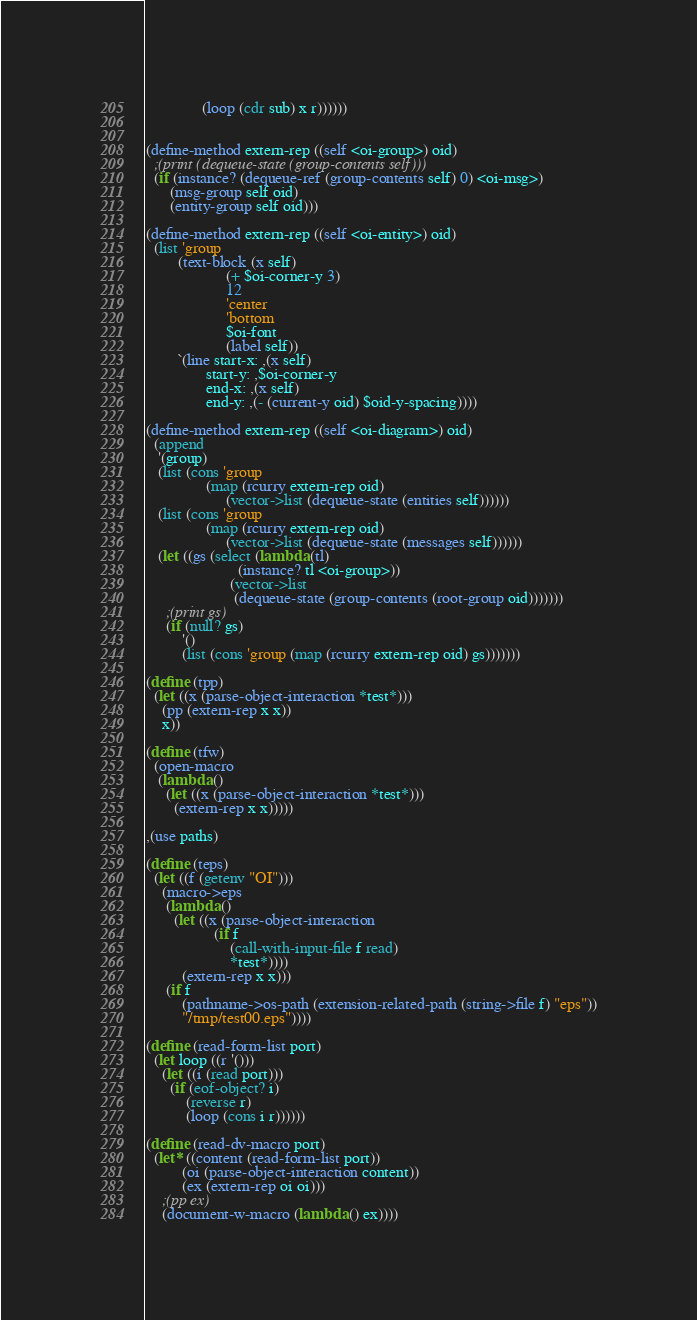Convert code to text. <code><loc_0><loc_0><loc_500><loc_500><_Scheme_>              (loop (cdr sub) x r))))))
        

(define-method extern-rep ((self <oi-group>) oid)
  ;(print (dequeue-state (group-contents self)))
  (if (instance? (dequeue-ref (group-contents self) 0) <oi-msg>)
      (msg-group self oid)
      (entity-group self oid)))

(define-method extern-rep ((self <oi-entity>) oid)
  (list 'group
        (text-block (x self)
                    (+ $oi-corner-y 3)
                    12
                    'center
                    'bottom
                    $oi-font
                    (label self))
        `(line start-x: ,(x self)
               start-y: ,$oi-corner-y
               end-x: ,(x self)
               end-y: ,(- (current-y oid) $oid-y-spacing))))
          
(define-method extern-rep ((self <oi-diagram>) oid)
  (append
   '(group)
   (list (cons 'group
               (map (rcurry extern-rep oid)
                    (vector->list (dequeue-state (entities self))))))
   (list (cons 'group
               (map (rcurry extern-rep oid)
                    (vector->list (dequeue-state (messages self))))))
   (let ((gs (select (lambda (tl)
                       (instance? tl <oi-group>))
                     (vector->list
                      (dequeue-state (group-contents (root-group oid)))))))
     ;(print gs)
     (if (null? gs)
         '()
         (list (cons 'group (map (rcurry extern-rep oid) gs)))))))

(define (tpp)
  (let ((x (parse-object-interaction *test*)))
    (pp (extern-rep x x))
    x))

(define (tfw)
  (open-macro
   (lambda ()
     (let ((x (parse-object-interaction *test*)))
       (extern-rep x x)))))

,(use paths)

(define (teps)
  (let ((f (getenv "OI")))
    (macro->eps
     (lambda ()
       (let ((x (parse-object-interaction 
                 (if f
                     (call-with-input-file f read)
                     *test*))))
         (extern-rep x x)))
     (if f
         (pathname->os-path (extension-related-path (string->file f) "eps"))
         "/tmp/test00.eps"))))

(define (read-form-list port)
  (let loop ((r '()))
    (let ((i (read port)))
      (if (eof-object? i)
          (reverse r)
          (loop (cons i r))))))

(define (read-dv-macro port)
  (let* ((content (read-form-list port))
         (oi (parse-object-interaction content))
         (ex (extern-rep oi oi)))
    ;(pp ex)
    (document-w-macro (lambda () ex))))
</code> 